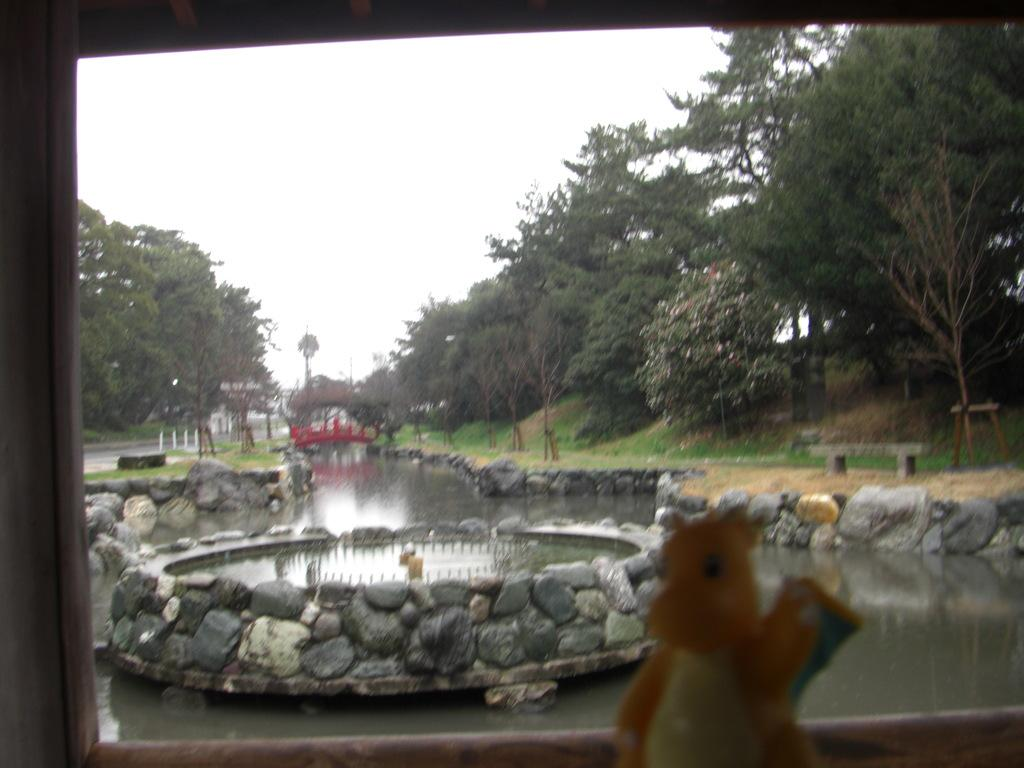What object can be seen in the image that is not a natural element? There is a toy in the image. What natural element is present in the image that is not a plant or rock? There is water in the image. What natural elements are present in the background of the image? There is grass and trees in the background of the image. What other natural elements are present in the image besides water? There are rocks in the image. What type of breakfast is being prepared in the image? There is no indication of breakfast preparation in the image; it features a toy, water, rocks, grass, and trees. Can you describe the attempt made by the toy to sneeze in the image? Toys do not have the ability to sneeze, and there is no such action depicted in the image. 